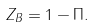<formula> <loc_0><loc_0><loc_500><loc_500>Z _ { B } = 1 - \Pi .</formula> 